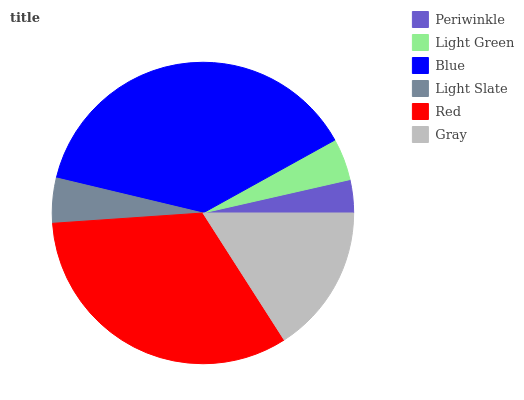Is Periwinkle the minimum?
Answer yes or no. Yes. Is Blue the maximum?
Answer yes or no. Yes. Is Light Green the minimum?
Answer yes or no. No. Is Light Green the maximum?
Answer yes or no. No. Is Light Green greater than Periwinkle?
Answer yes or no. Yes. Is Periwinkle less than Light Green?
Answer yes or no. Yes. Is Periwinkle greater than Light Green?
Answer yes or no. No. Is Light Green less than Periwinkle?
Answer yes or no. No. Is Gray the high median?
Answer yes or no. Yes. Is Light Slate the low median?
Answer yes or no. Yes. Is Blue the high median?
Answer yes or no. No. Is Red the low median?
Answer yes or no. No. 